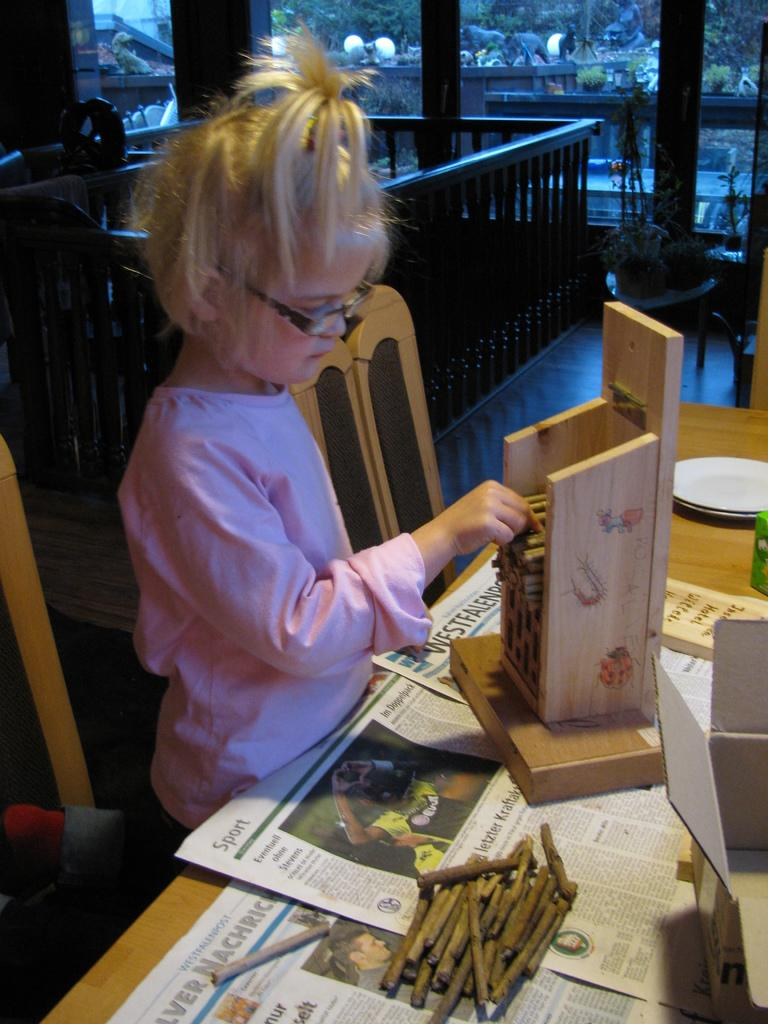What is the main subject of the image? The main subject of the image is a kid. What is the kid wearing? The kid is wearing clothes. Where is the kid standing in relation to the table? The kid is standing in front of a table. What items can be seen on the table? The table contains boxes, plates, and sticks. What piece of furniture is in the middle of the image? There is a chair in the middle of the image. What type of noise can be heard coming from the operation in the image? There is no operation or noise present in the image; it features a kid standing in front of a table with boxes, plates, and sticks, and a chair in the middle of the image. 